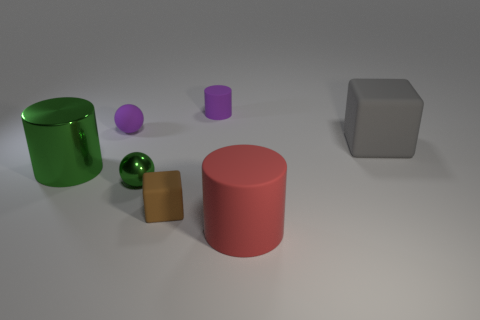Add 1 big brown things. How many objects exist? 8 Subtract all cylinders. How many objects are left? 4 Add 3 big green rubber spheres. How many big green rubber spheres exist? 3 Subtract 0 cyan balls. How many objects are left? 7 Subtract all purple metal objects. Subtract all gray matte cubes. How many objects are left? 6 Add 7 small metallic things. How many small metallic things are left? 8 